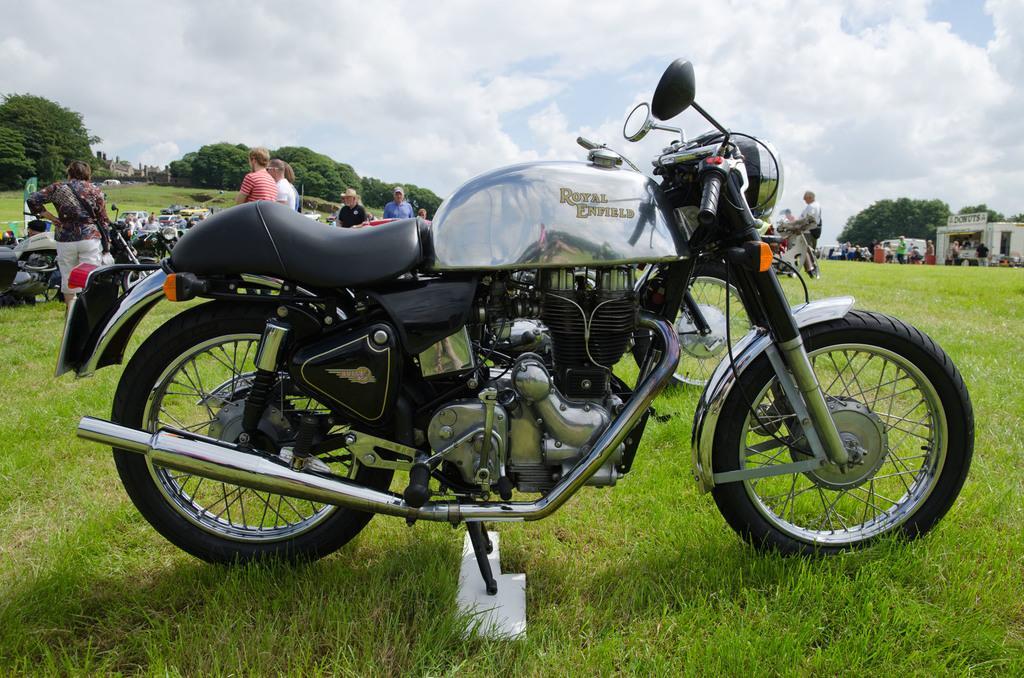Describe this image in one or two sentences. In the center of the image we can see bike. In the background we can see persons, likes, cars, vehicles, trees, buildings, sky and clouds. At the bottom there is grass. 